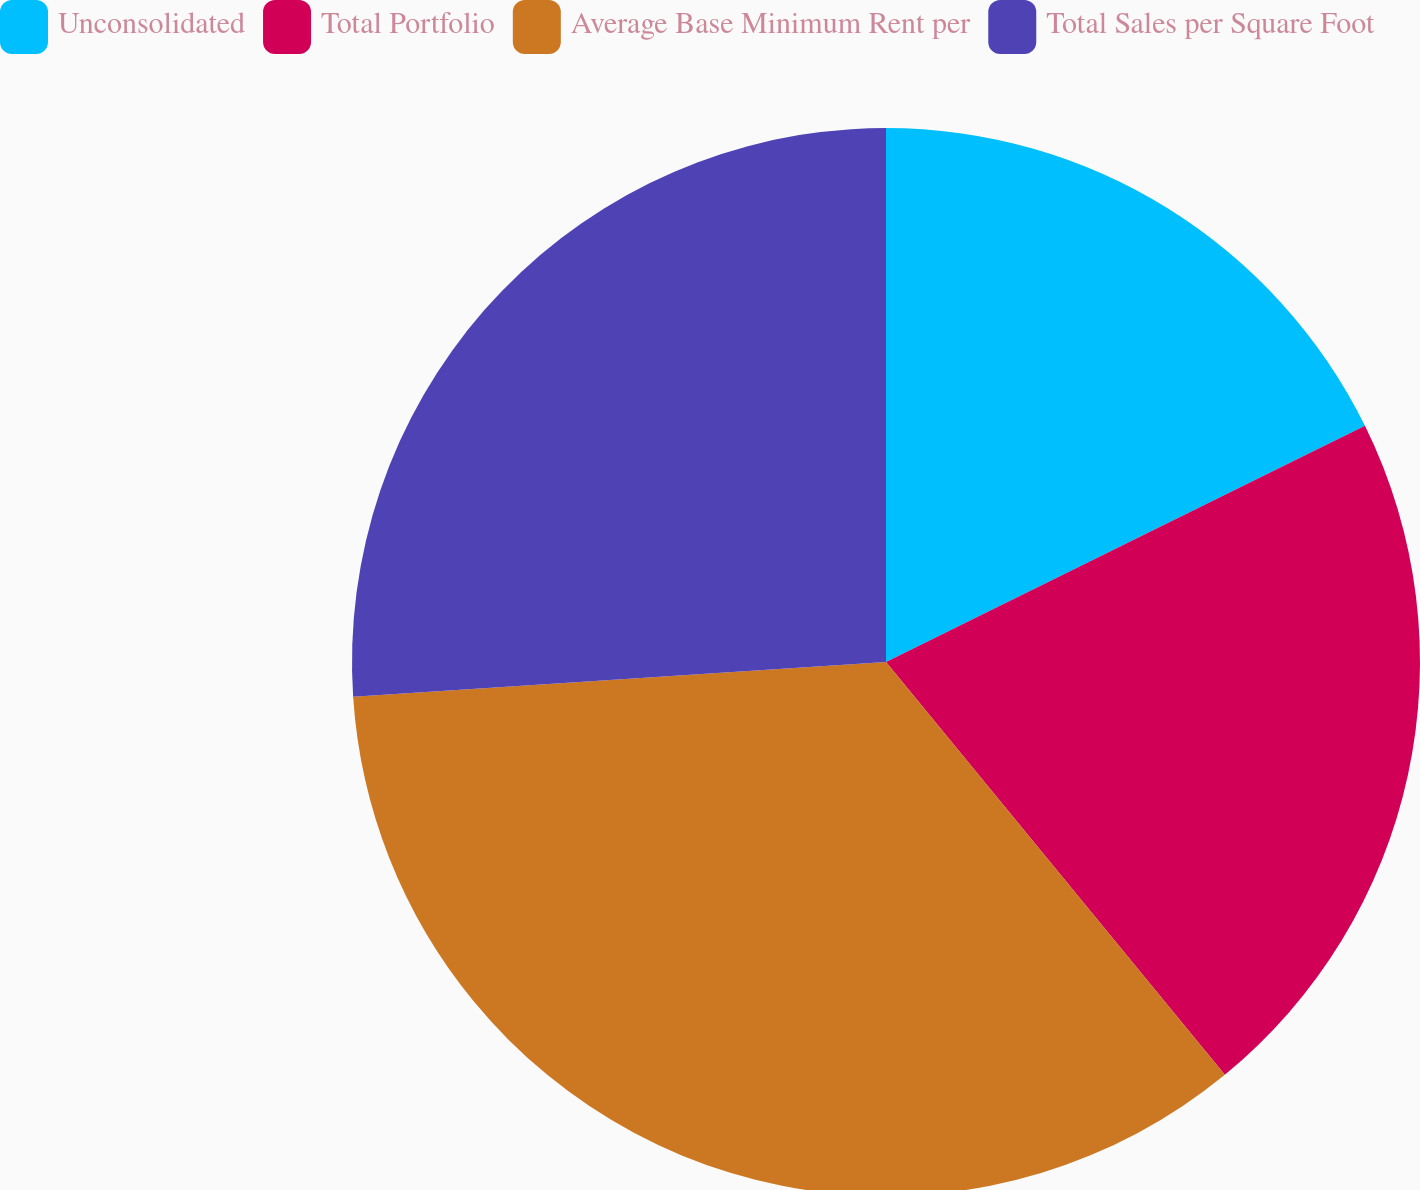Convert chart. <chart><loc_0><loc_0><loc_500><loc_500><pie_chart><fcel>Unconsolidated<fcel>Total Portfolio<fcel>Average Base Minimum Rent per<fcel>Total Sales per Square Foot<nl><fcel>17.71%<fcel>21.35%<fcel>34.9%<fcel>26.04%<nl></chart> 